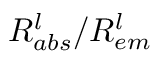<formula> <loc_0><loc_0><loc_500><loc_500>R _ { a b s } ^ { l } / R _ { e m } ^ { l }</formula> 